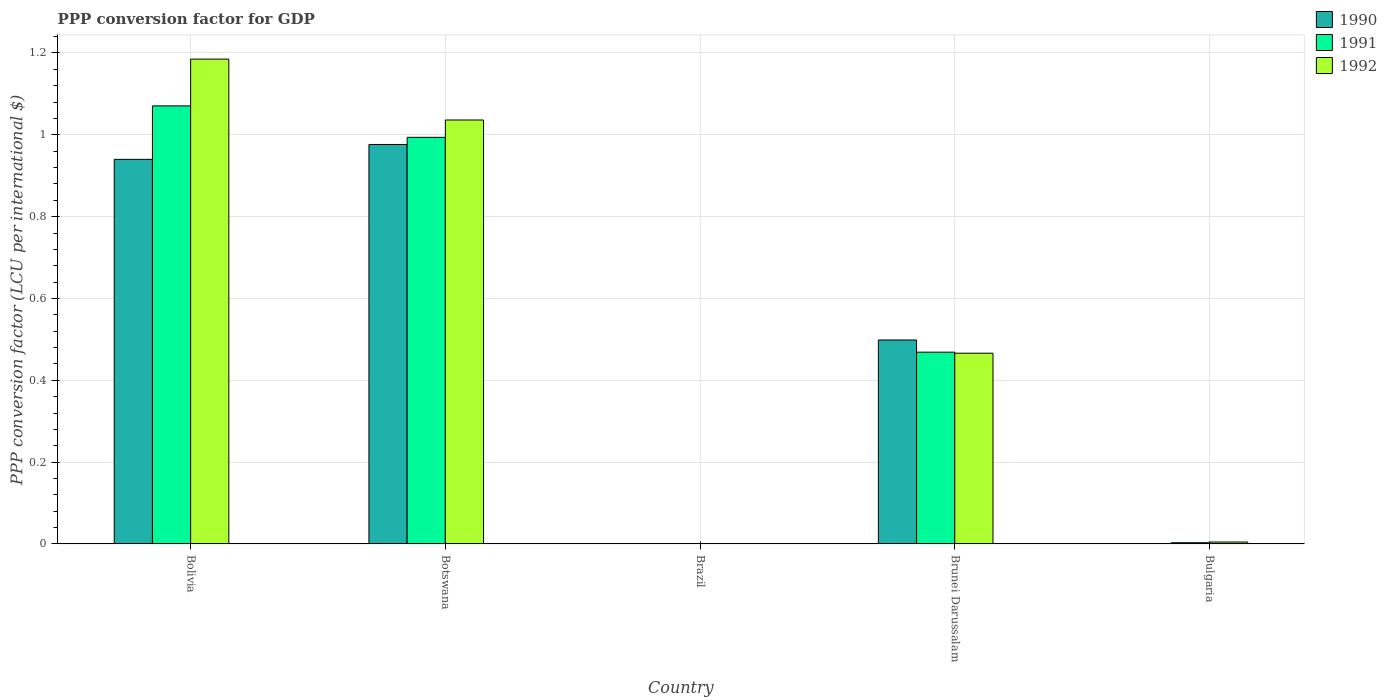How many different coloured bars are there?
Your answer should be very brief. 3. Are the number of bars per tick equal to the number of legend labels?
Offer a very short reply. Yes. How many bars are there on the 5th tick from the left?
Keep it short and to the point. 3. What is the label of the 4th group of bars from the left?
Make the answer very short. Brunei Darussalam. What is the PPP conversion factor for GDP in 1990 in Bolivia?
Your answer should be compact. 0.94. Across all countries, what is the maximum PPP conversion factor for GDP in 1991?
Offer a terse response. 1.07. Across all countries, what is the minimum PPP conversion factor for GDP in 1990?
Your answer should be compact. 1.1557525272828e-5. In which country was the PPP conversion factor for GDP in 1990 maximum?
Give a very brief answer. Botswana. What is the total PPP conversion factor for GDP in 1991 in the graph?
Your answer should be compact. 2.54. What is the difference between the PPP conversion factor for GDP in 1990 in Bolivia and that in Brunei Darussalam?
Ensure brevity in your answer.  0.44. What is the difference between the PPP conversion factor for GDP in 1990 in Bulgaria and the PPP conversion factor for GDP in 1992 in Brazil?
Your answer should be very brief. 0. What is the average PPP conversion factor for GDP in 1990 per country?
Your response must be concise. 0.48. What is the difference between the PPP conversion factor for GDP of/in 1991 and PPP conversion factor for GDP of/in 1990 in Brunei Darussalam?
Ensure brevity in your answer.  -0.03. What is the ratio of the PPP conversion factor for GDP in 1992 in Brunei Darussalam to that in Bulgaria?
Provide a short and direct response. 98.24. Is the PPP conversion factor for GDP in 1992 in Brazil less than that in Brunei Darussalam?
Keep it short and to the point. Yes. What is the difference between the highest and the second highest PPP conversion factor for GDP in 1991?
Your answer should be compact. -0.08. What is the difference between the highest and the lowest PPP conversion factor for GDP in 1991?
Make the answer very short. 1.07. Is the sum of the PPP conversion factor for GDP in 1990 in Bolivia and Botswana greater than the maximum PPP conversion factor for GDP in 1991 across all countries?
Give a very brief answer. Yes. What does the 1st bar from the left in Bulgaria represents?
Provide a short and direct response. 1990. How many bars are there?
Provide a succinct answer. 15. Are all the bars in the graph horizontal?
Your answer should be compact. No. Are the values on the major ticks of Y-axis written in scientific E-notation?
Offer a terse response. No. Does the graph contain any zero values?
Your answer should be very brief. No. Does the graph contain grids?
Your answer should be very brief. Yes. Where does the legend appear in the graph?
Make the answer very short. Top right. How are the legend labels stacked?
Give a very brief answer. Vertical. What is the title of the graph?
Keep it short and to the point. PPP conversion factor for GDP. Does "1979" appear as one of the legend labels in the graph?
Keep it short and to the point. No. What is the label or title of the Y-axis?
Provide a succinct answer. PPP conversion factor (LCU per international $). What is the PPP conversion factor (LCU per international $) in 1990 in Bolivia?
Ensure brevity in your answer.  0.94. What is the PPP conversion factor (LCU per international $) of 1991 in Bolivia?
Your answer should be very brief. 1.07. What is the PPP conversion factor (LCU per international $) in 1992 in Bolivia?
Provide a short and direct response. 1.18. What is the PPP conversion factor (LCU per international $) in 1990 in Botswana?
Provide a short and direct response. 0.98. What is the PPP conversion factor (LCU per international $) of 1991 in Botswana?
Your response must be concise. 0.99. What is the PPP conversion factor (LCU per international $) of 1992 in Botswana?
Your answer should be very brief. 1.04. What is the PPP conversion factor (LCU per international $) of 1990 in Brazil?
Make the answer very short. 1.1557525272828e-5. What is the PPP conversion factor (LCU per international $) of 1991 in Brazil?
Offer a very short reply. 5.75184759112572e-5. What is the PPP conversion factor (LCU per international $) of 1992 in Brazil?
Your response must be concise. 0. What is the PPP conversion factor (LCU per international $) of 1990 in Brunei Darussalam?
Give a very brief answer. 0.5. What is the PPP conversion factor (LCU per international $) in 1991 in Brunei Darussalam?
Your response must be concise. 0.47. What is the PPP conversion factor (LCU per international $) in 1992 in Brunei Darussalam?
Your answer should be compact. 0.47. What is the PPP conversion factor (LCU per international $) in 1990 in Bulgaria?
Your response must be concise. 0. What is the PPP conversion factor (LCU per international $) of 1991 in Bulgaria?
Your answer should be very brief. 0. What is the PPP conversion factor (LCU per international $) of 1992 in Bulgaria?
Keep it short and to the point. 0. Across all countries, what is the maximum PPP conversion factor (LCU per international $) in 1990?
Give a very brief answer. 0.98. Across all countries, what is the maximum PPP conversion factor (LCU per international $) in 1991?
Ensure brevity in your answer.  1.07. Across all countries, what is the maximum PPP conversion factor (LCU per international $) of 1992?
Keep it short and to the point. 1.18. Across all countries, what is the minimum PPP conversion factor (LCU per international $) in 1990?
Your response must be concise. 1.1557525272828e-5. Across all countries, what is the minimum PPP conversion factor (LCU per international $) of 1991?
Ensure brevity in your answer.  5.75184759112572e-5. Across all countries, what is the minimum PPP conversion factor (LCU per international $) of 1992?
Ensure brevity in your answer.  0. What is the total PPP conversion factor (LCU per international $) in 1990 in the graph?
Make the answer very short. 2.42. What is the total PPP conversion factor (LCU per international $) in 1991 in the graph?
Ensure brevity in your answer.  2.54. What is the total PPP conversion factor (LCU per international $) of 1992 in the graph?
Make the answer very short. 2.69. What is the difference between the PPP conversion factor (LCU per international $) of 1990 in Bolivia and that in Botswana?
Your answer should be very brief. -0.04. What is the difference between the PPP conversion factor (LCU per international $) of 1991 in Bolivia and that in Botswana?
Give a very brief answer. 0.08. What is the difference between the PPP conversion factor (LCU per international $) in 1992 in Bolivia and that in Botswana?
Provide a succinct answer. 0.15. What is the difference between the PPP conversion factor (LCU per international $) of 1991 in Bolivia and that in Brazil?
Offer a terse response. 1.07. What is the difference between the PPP conversion factor (LCU per international $) of 1992 in Bolivia and that in Brazil?
Offer a very short reply. 1.18. What is the difference between the PPP conversion factor (LCU per international $) of 1990 in Bolivia and that in Brunei Darussalam?
Provide a succinct answer. 0.44. What is the difference between the PPP conversion factor (LCU per international $) in 1991 in Bolivia and that in Brunei Darussalam?
Your answer should be compact. 0.6. What is the difference between the PPP conversion factor (LCU per international $) of 1992 in Bolivia and that in Brunei Darussalam?
Offer a very short reply. 0.72. What is the difference between the PPP conversion factor (LCU per international $) in 1990 in Bolivia and that in Bulgaria?
Offer a very short reply. 0.94. What is the difference between the PPP conversion factor (LCU per international $) of 1991 in Bolivia and that in Bulgaria?
Your answer should be very brief. 1.07. What is the difference between the PPP conversion factor (LCU per international $) in 1992 in Bolivia and that in Bulgaria?
Offer a very short reply. 1.18. What is the difference between the PPP conversion factor (LCU per international $) of 1990 in Botswana and that in Brazil?
Offer a terse response. 0.98. What is the difference between the PPP conversion factor (LCU per international $) of 1992 in Botswana and that in Brazil?
Give a very brief answer. 1.04. What is the difference between the PPP conversion factor (LCU per international $) of 1990 in Botswana and that in Brunei Darussalam?
Your response must be concise. 0.48. What is the difference between the PPP conversion factor (LCU per international $) of 1991 in Botswana and that in Brunei Darussalam?
Offer a terse response. 0.53. What is the difference between the PPP conversion factor (LCU per international $) in 1992 in Botswana and that in Brunei Darussalam?
Your answer should be very brief. 0.57. What is the difference between the PPP conversion factor (LCU per international $) in 1990 in Botswana and that in Bulgaria?
Keep it short and to the point. 0.98. What is the difference between the PPP conversion factor (LCU per international $) in 1992 in Botswana and that in Bulgaria?
Give a very brief answer. 1.03. What is the difference between the PPP conversion factor (LCU per international $) in 1990 in Brazil and that in Brunei Darussalam?
Give a very brief answer. -0.5. What is the difference between the PPP conversion factor (LCU per international $) of 1991 in Brazil and that in Brunei Darussalam?
Make the answer very short. -0.47. What is the difference between the PPP conversion factor (LCU per international $) in 1992 in Brazil and that in Brunei Darussalam?
Provide a short and direct response. -0.47. What is the difference between the PPP conversion factor (LCU per international $) in 1990 in Brazil and that in Bulgaria?
Your response must be concise. -0. What is the difference between the PPP conversion factor (LCU per international $) of 1991 in Brazil and that in Bulgaria?
Provide a short and direct response. -0. What is the difference between the PPP conversion factor (LCU per international $) of 1992 in Brazil and that in Bulgaria?
Provide a short and direct response. -0. What is the difference between the PPP conversion factor (LCU per international $) of 1990 in Brunei Darussalam and that in Bulgaria?
Keep it short and to the point. 0.5. What is the difference between the PPP conversion factor (LCU per international $) in 1991 in Brunei Darussalam and that in Bulgaria?
Ensure brevity in your answer.  0.47. What is the difference between the PPP conversion factor (LCU per international $) in 1992 in Brunei Darussalam and that in Bulgaria?
Offer a very short reply. 0.46. What is the difference between the PPP conversion factor (LCU per international $) of 1990 in Bolivia and the PPP conversion factor (LCU per international $) of 1991 in Botswana?
Make the answer very short. -0.05. What is the difference between the PPP conversion factor (LCU per international $) of 1990 in Bolivia and the PPP conversion factor (LCU per international $) of 1992 in Botswana?
Your answer should be very brief. -0.1. What is the difference between the PPP conversion factor (LCU per international $) of 1991 in Bolivia and the PPP conversion factor (LCU per international $) of 1992 in Botswana?
Provide a succinct answer. 0.03. What is the difference between the PPP conversion factor (LCU per international $) in 1990 in Bolivia and the PPP conversion factor (LCU per international $) in 1991 in Brazil?
Provide a succinct answer. 0.94. What is the difference between the PPP conversion factor (LCU per international $) in 1990 in Bolivia and the PPP conversion factor (LCU per international $) in 1992 in Brazil?
Offer a very short reply. 0.94. What is the difference between the PPP conversion factor (LCU per international $) of 1991 in Bolivia and the PPP conversion factor (LCU per international $) of 1992 in Brazil?
Give a very brief answer. 1.07. What is the difference between the PPP conversion factor (LCU per international $) of 1990 in Bolivia and the PPP conversion factor (LCU per international $) of 1991 in Brunei Darussalam?
Make the answer very short. 0.47. What is the difference between the PPP conversion factor (LCU per international $) of 1990 in Bolivia and the PPP conversion factor (LCU per international $) of 1992 in Brunei Darussalam?
Make the answer very short. 0.47. What is the difference between the PPP conversion factor (LCU per international $) of 1991 in Bolivia and the PPP conversion factor (LCU per international $) of 1992 in Brunei Darussalam?
Ensure brevity in your answer.  0.6. What is the difference between the PPP conversion factor (LCU per international $) of 1990 in Bolivia and the PPP conversion factor (LCU per international $) of 1991 in Bulgaria?
Make the answer very short. 0.94. What is the difference between the PPP conversion factor (LCU per international $) of 1990 in Bolivia and the PPP conversion factor (LCU per international $) of 1992 in Bulgaria?
Your answer should be very brief. 0.94. What is the difference between the PPP conversion factor (LCU per international $) of 1991 in Bolivia and the PPP conversion factor (LCU per international $) of 1992 in Bulgaria?
Your answer should be compact. 1.07. What is the difference between the PPP conversion factor (LCU per international $) of 1990 in Botswana and the PPP conversion factor (LCU per international $) of 1991 in Brazil?
Give a very brief answer. 0.98. What is the difference between the PPP conversion factor (LCU per international $) of 1990 in Botswana and the PPP conversion factor (LCU per international $) of 1992 in Brazil?
Your response must be concise. 0.98. What is the difference between the PPP conversion factor (LCU per international $) of 1990 in Botswana and the PPP conversion factor (LCU per international $) of 1991 in Brunei Darussalam?
Give a very brief answer. 0.51. What is the difference between the PPP conversion factor (LCU per international $) in 1990 in Botswana and the PPP conversion factor (LCU per international $) in 1992 in Brunei Darussalam?
Provide a short and direct response. 0.51. What is the difference between the PPP conversion factor (LCU per international $) in 1991 in Botswana and the PPP conversion factor (LCU per international $) in 1992 in Brunei Darussalam?
Keep it short and to the point. 0.53. What is the difference between the PPP conversion factor (LCU per international $) of 1990 in Botswana and the PPP conversion factor (LCU per international $) of 1991 in Bulgaria?
Offer a very short reply. 0.97. What is the difference between the PPP conversion factor (LCU per international $) of 1990 in Botswana and the PPP conversion factor (LCU per international $) of 1992 in Bulgaria?
Give a very brief answer. 0.97. What is the difference between the PPP conversion factor (LCU per international $) in 1990 in Brazil and the PPP conversion factor (LCU per international $) in 1991 in Brunei Darussalam?
Keep it short and to the point. -0.47. What is the difference between the PPP conversion factor (LCU per international $) in 1990 in Brazil and the PPP conversion factor (LCU per international $) in 1992 in Brunei Darussalam?
Your answer should be compact. -0.47. What is the difference between the PPP conversion factor (LCU per international $) of 1991 in Brazil and the PPP conversion factor (LCU per international $) of 1992 in Brunei Darussalam?
Ensure brevity in your answer.  -0.47. What is the difference between the PPP conversion factor (LCU per international $) in 1990 in Brazil and the PPP conversion factor (LCU per international $) in 1991 in Bulgaria?
Ensure brevity in your answer.  -0. What is the difference between the PPP conversion factor (LCU per international $) of 1990 in Brazil and the PPP conversion factor (LCU per international $) of 1992 in Bulgaria?
Give a very brief answer. -0. What is the difference between the PPP conversion factor (LCU per international $) in 1991 in Brazil and the PPP conversion factor (LCU per international $) in 1992 in Bulgaria?
Provide a short and direct response. -0. What is the difference between the PPP conversion factor (LCU per international $) in 1990 in Brunei Darussalam and the PPP conversion factor (LCU per international $) in 1991 in Bulgaria?
Offer a terse response. 0.5. What is the difference between the PPP conversion factor (LCU per international $) of 1990 in Brunei Darussalam and the PPP conversion factor (LCU per international $) of 1992 in Bulgaria?
Offer a very short reply. 0.49. What is the difference between the PPP conversion factor (LCU per international $) in 1991 in Brunei Darussalam and the PPP conversion factor (LCU per international $) in 1992 in Bulgaria?
Your response must be concise. 0.46. What is the average PPP conversion factor (LCU per international $) of 1990 per country?
Your answer should be very brief. 0.48. What is the average PPP conversion factor (LCU per international $) in 1991 per country?
Provide a short and direct response. 0.51. What is the average PPP conversion factor (LCU per international $) of 1992 per country?
Your answer should be very brief. 0.54. What is the difference between the PPP conversion factor (LCU per international $) of 1990 and PPP conversion factor (LCU per international $) of 1991 in Bolivia?
Provide a succinct answer. -0.13. What is the difference between the PPP conversion factor (LCU per international $) of 1990 and PPP conversion factor (LCU per international $) of 1992 in Bolivia?
Give a very brief answer. -0.24. What is the difference between the PPP conversion factor (LCU per international $) of 1991 and PPP conversion factor (LCU per international $) of 1992 in Bolivia?
Ensure brevity in your answer.  -0.11. What is the difference between the PPP conversion factor (LCU per international $) of 1990 and PPP conversion factor (LCU per international $) of 1991 in Botswana?
Offer a very short reply. -0.02. What is the difference between the PPP conversion factor (LCU per international $) of 1990 and PPP conversion factor (LCU per international $) of 1992 in Botswana?
Offer a terse response. -0.06. What is the difference between the PPP conversion factor (LCU per international $) in 1991 and PPP conversion factor (LCU per international $) in 1992 in Botswana?
Keep it short and to the point. -0.04. What is the difference between the PPP conversion factor (LCU per international $) of 1990 and PPP conversion factor (LCU per international $) of 1991 in Brazil?
Offer a very short reply. -0. What is the difference between the PPP conversion factor (LCU per international $) of 1990 and PPP conversion factor (LCU per international $) of 1992 in Brazil?
Give a very brief answer. -0. What is the difference between the PPP conversion factor (LCU per international $) in 1991 and PPP conversion factor (LCU per international $) in 1992 in Brazil?
Keep it short and to the point. -0. What is the difference between the PPP conversion factor (LCU per international $) in 1990 and PPP conversion factor (LCU per international $) in 1991 in Brunei Darussalam?
Your answer should be compact. 0.03. What is the difference between the PPP conversion factor (LCU per international $) in 1990 and PPP conversion factor (LCU per international $) in 1992 in Brunei Darussalam?
Your answer should be compact. 0.03. What is the difference between the PPP conversion factor (LCU per international $) of 1991 and PPP conversion factor (LCU per international $) of 1992 in Brunei Darussalam?
Offer a very short reply. 0. What is the difference between the PPP conversion factor (LCU per international $) in 1990 and PPP conversion factor (LCU per international $) in 1991 in Bulgaria?
Your answer should be compact. -0. What is the difference between the PPP conversion factor (LCU per international $) of 1990 and PPP conversion factor (LCU per international $) of 1992 in Bulgaria?
Your answer should be compact. -0. What is the difference between the PPP conversion factor (LCU per international $) of 1991 and PPP conversion factor (LCU per international $) of 1992 in Bulgaria?
Provide a short and direct response. -0. What is the ratio of the PPP conversion factor (LCU per international $) in 1990 in Bolivia to that in Botswana?
Your answer should be very brief. 0.96. What is the ratio of the PPP conversion factor (LCU per international $) of 1991 in Bolivia to that in Botswana?
Your answer should be very brief. 1.08. What is the ratio of the PPP conversion factor (LCU per international $) in 1992 in Bolivia to that in Botswana?
Offer a terse response. 1.14. What is the ratio of the PPP conversion factor (LCU per international $) in 1990 in Bolivia to that in Brazil?
Provide a short and direct response. 8.13e+04. What is the ratio of the PPP conversion factor (LCU per international $) of 1991 in Bolivia to that in Brazil?
Your answer should be compact. 1.86e+04. What is the ratio of the PPP conversion factor (LCU per international $) in 1992 in Bolivia to that in Brazil?
Offer a very short reply. 1972.64. What is the ratio of the PPP conversion factor (LCU per international $) of 1990 in Bolivia to that in Brunei Darussalam?
Give a very brief answer. 1.89. What is the ratio of the PPP conversion factor (LCU per international $) in 1991 in Bolivia to that in Brunei Darussalam?
Ensure brevity in your answer.  2.28. What is the ratio of the PPP conversion factor (LCU per international $) in 1992 in Bolivia to that in Brunei Darussalam?
Offer a terse response. 2.54. What is the ratio of the PPP conversion factor (LCU per international $) in 1990 in Bolivia to that in Bulgaria?
Ensure brevity in your answer.  976.62. What is the ratio of the PPP conversion factor (LCU per international $) in 1991 in Bolivia to that in Bulgaria?
Make the answer very short. 351.99. What is the ratio of the PPP conversion factor (LCU per international $) of 1992 in Bolivia to that in Bulgaria?
Your answer should be very brief. 249.69. What is the ratio of the PPP conversion factor (LCU per international $) in 1990 in Botswana to that in Brazil?
Offer a very short reply. 8.45e+04. What is the ratio of the PPP conversion factor (LCU per international $) in 1991 in Botswana to that in Brazil?
Provide a succinct answer. 1.73e+04. What is the ratio of the PPP conversion factor (LCU per international $) in 1992 in Botswana to that in Brazil?
Your answer should be compact. 1724.96. What is the ratio of the PPP conversion factor (LCU per international $) of 1990 in Botswana to that in Brunei Darussalam?
Ensure brevity in your answer.  1.96. What is the ratio of the PPP conversion factor (LCU per international $) in 1991 in Botswana to that in Brunei Darussalam?
Provide a short and direct response. 2.12. What is the ratio of the PPP conversion factor (LCU per international $) of 1992 in Botswana to that in Brunei Darussalam?
Give a very brief answer. 2.22. What is the ratio of the PPP conversion factor (LCU per international $) of 1990 in Botswana to that in Bulgaria?
Make the answer very short. 1014.36. What is the ratio of the PPP conversion factor (LCU per international $) in 1991 in Botswana to that in Bulgaria?
Keep it short and to the point. 326.73. What is the ratio of the PPP conversion factor (LCU per international $) of 1992 in Botswana to that in Bulgaria?
Make the answer very short. 218.34. What is the ratio of the PPP conversion factor (LCU per international $) of 1992 in Brazil to that in Brunei Darussalam?
Provide a succinct answer. 0. What is the ratio of the PPP conversion factor (LCU per international $) of 1990 in Brazil to that in Bulgaria?
Your response must be concise. 0.01. What is the ratio of the PPP conversion factor (LCU per international $) in 1991 in Brazil to that in Bulgaria?
Give a very brief answer. 0.02. What is the ratio of the PPP conversion factor (LCU per international $) of 1992 in Brazil to that in Bulgaria?
Ensure brevity in your answer.  0.13. What is the ratio of the PPP conversion factor (LCU per international $) of 1990 in Brunei Darussalam to that in Bulgaria?
Offer a very short reply. 517.94. What is the ratio of the PPP conversion factor (LCU per international $) of 1991 in Brunei Darussalam to that in Bulgaria?
Your response must be concise. 154.12. What is the ratio of the PPP conversion factor (LCU per international $) of 1992 in Brunei Darussalam to that in Bulgaria?
Provide a short and direct response. 98.24. What is the difference between the highest and the second highest PPP conversion factor (LCU per international $) in 1990?
Provide a succinct answer. 0.04. What is the difference between the highest and the second highest PPP conversion factor (LCU per international $) in 1991?
Keep it short and to the point. 0.08. What is the difference between the highest and the second highest PPP conversion factor (LCU per international $) of 1992?
Make the answer very short. 0.15. What is the difference between the highest and the lowest PPP conversion factor (LCU per international $) of 1990?
Your answer should be very brief. 0.98. What is the difference between the highest and the lowest PPP conversion factor (LCU per international $) in 1991?
Your answer should be very brief. 1.07. What is the difference between the highest and the lowest PPP conversion factor (LCU per international $) in 1992?
Provide a succinct answer. 1.18. 